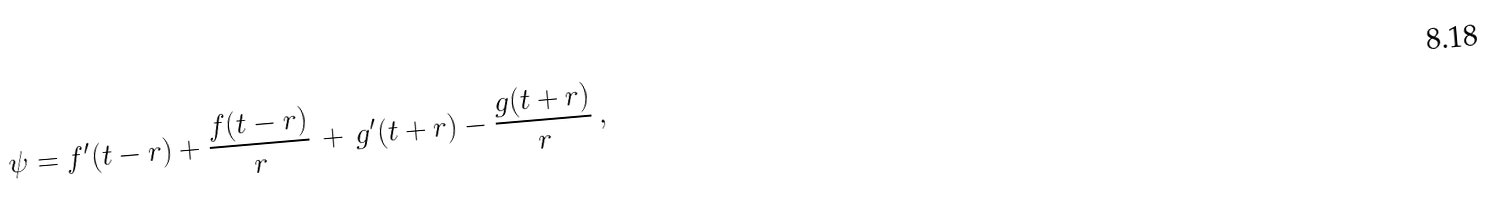<formula> <loc_0><loc_0><loc_500><loc_500>\psi = { f ^ { \prime } ( t - r ) } + \frac { f ( t - r ) } { r } \, + \, { g ^ { \prime } ( t + r ) } - \frac { g ( t + r ) } { r } \, ,</formula> 